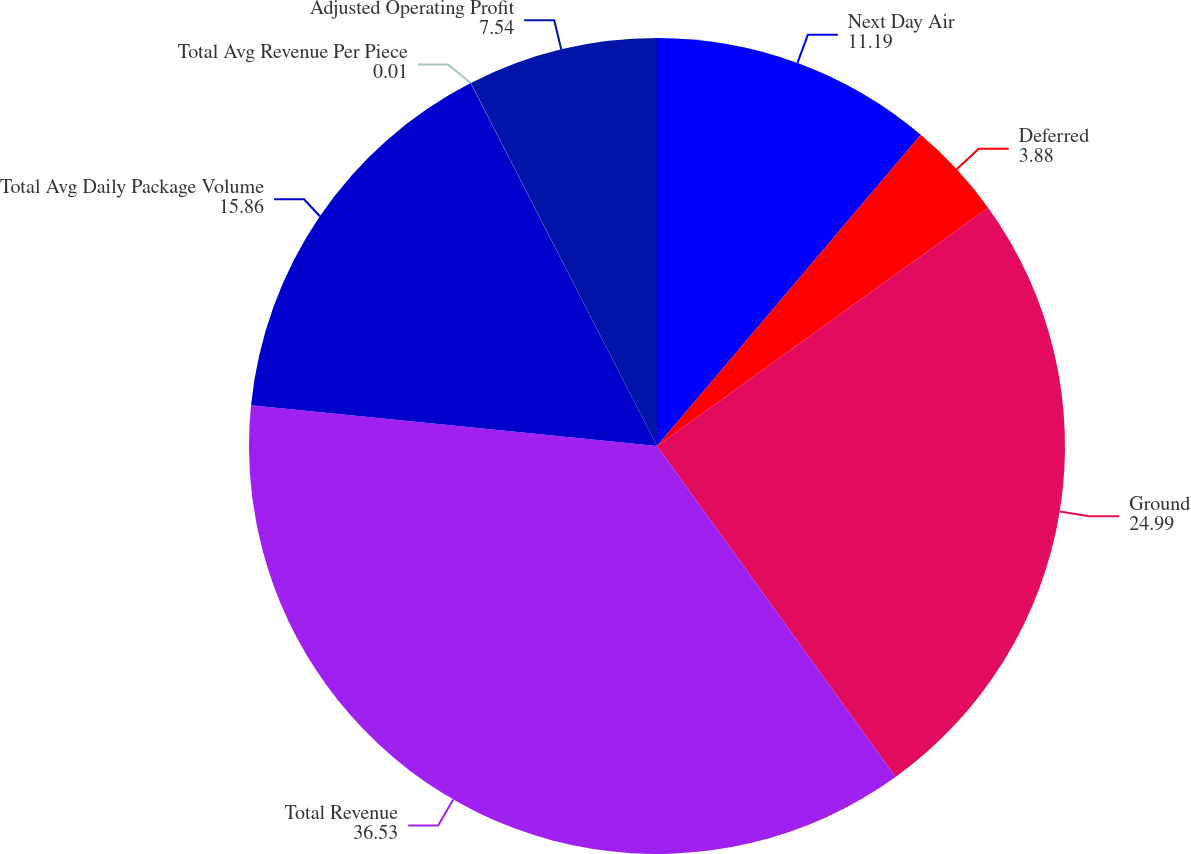Convert chart. <chart><loc_0><loc_0><loc_500><loc_500><pie_chart><fcel>Next Day Air<fcel>Deferred<fcel>Ground<fcel>Total Revenue<fcel>Total Avg Daily Package Volume<fcel>Total Avg Revenue Per Piece<fcel>Adjusted Operating Profit<nl><fcel>11.19%<fcel>3.88%<fcel>24.99%<fcel>36.53%<fcel>15.86%<fcel>0.01%<fcel>7.54%<nl></chart> 